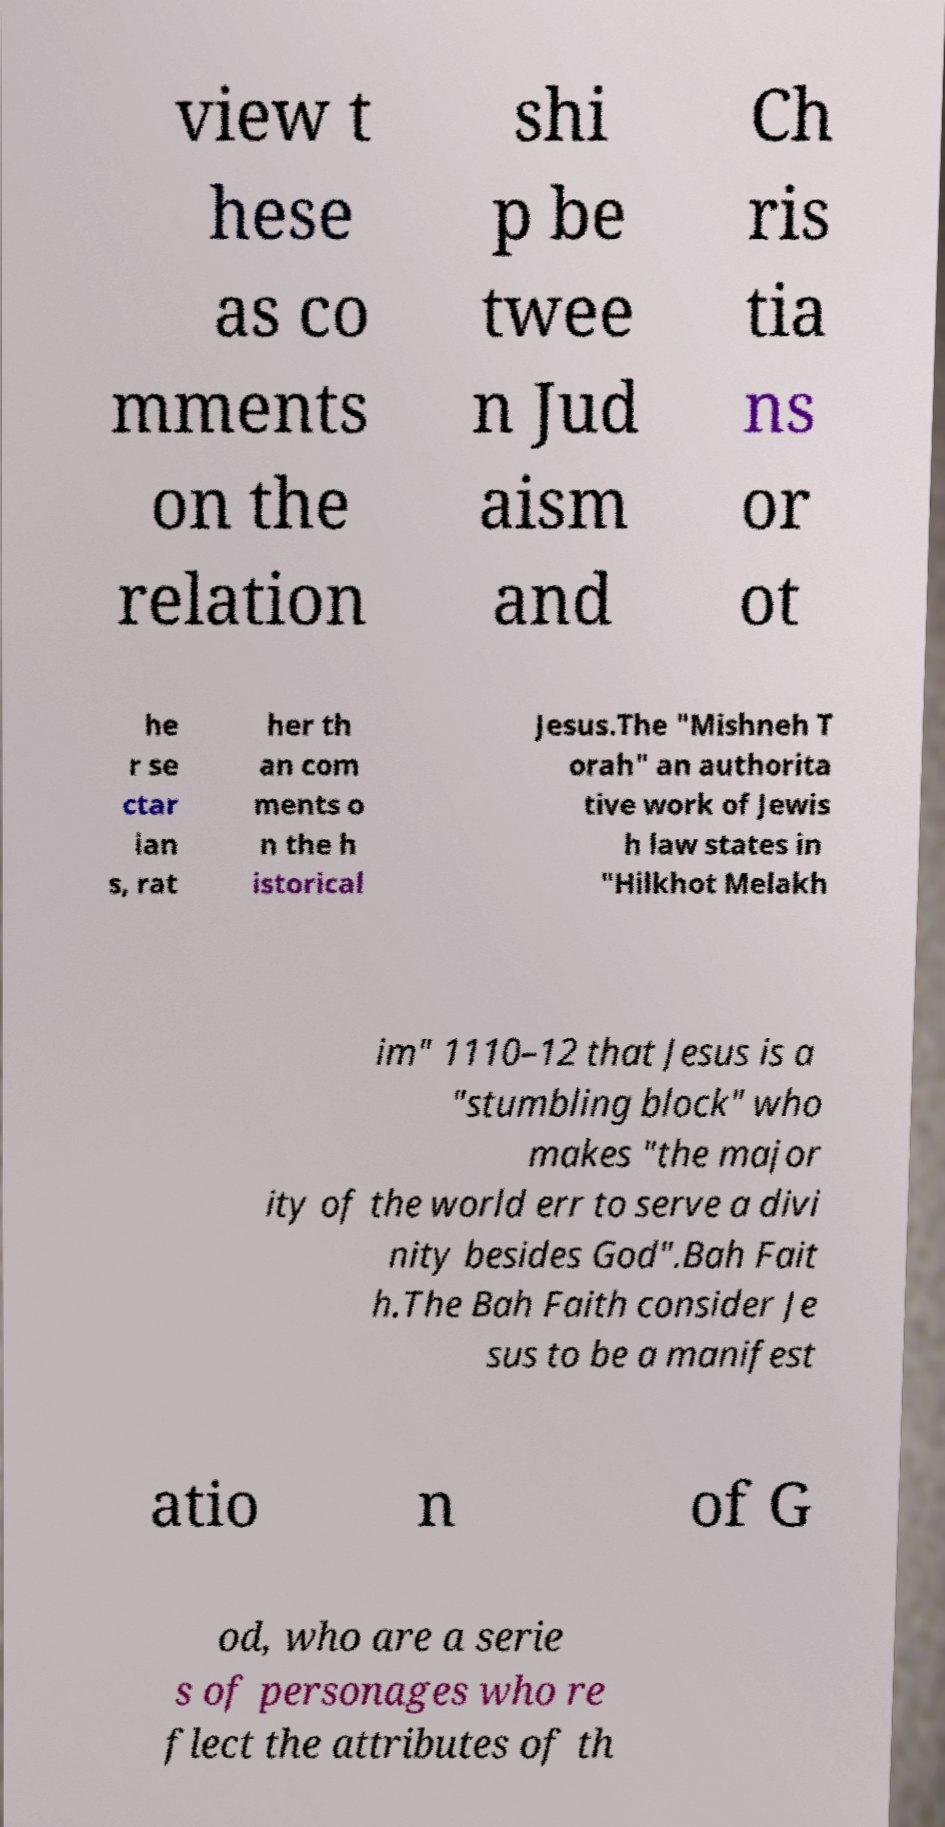Can you accurately transcribe the text from the provided image for me? view t hese as co mments on the relation shi p be twee n Jud aism and Ch ris tia ns or ot he r se ctar ian s, rat her th an com ments o n the h istorical Jesus.The "Mishneh T orah" an authorita tive work of Jewis h law states in "Hilkhot Melakh im" 1110–12 that Jesus is a "stumbling block" who makes "the major ity of the world err to serve a divi nity besides God".Bah Fait h.The Bah Faith consider Je sus to be a manifest atio n of G od, who are a serie s of personages who re flect the attributes of th 